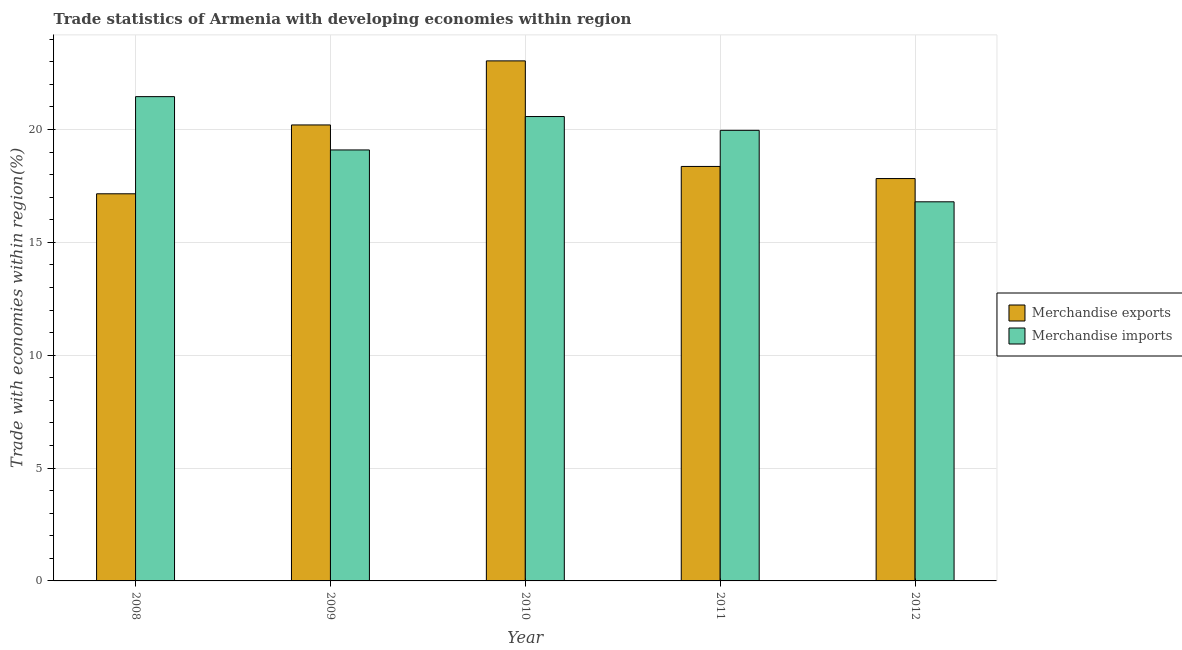How many different coloured bars are there?
Offer a very short reply. 2. Are the number of bars per tick equal to the number of legend labels?
Keep it short and to the point. Yes. Are the number of bars on each tick of the X-axis equal?
Provide a short and direct response. Yes. How many bars are there on the 4th tick from the left?
Your answer should be compact. 2. How many bars are there on the 4th tick from the right?
Provide a succinct answer. 2. What is the label of the 3rd group of bars from the left?
Offer a terse response. 2010. What is the merchandise exports in 2010?
Offer a terse response. 23.04. Across all years, what is the maximum merchandise imports?
Make the answer very short. 21.45. Across all years, what is the minimum merchandise imports?
Make the answer very short. 16.79. What is the total merchandise exports in the graph?
Your answer should be compact. 96.57. What is the difference between the merchandise exports in 2009 and that in 2011?
Offer a terse response. 1.84. What is the difference between the merchandise imports in 2012 and the merchandise exports in 2008?
Give a very brief answer. -4.66. What is the average merchandise exports per year?
Offer a terse response. 19.31. What is the ratio of the merchandise imports in 2010 to that in 2011?
Give a very brief answer. 1.03. Is the difference between the merchandise imports in 2008 and 2010 greater than the difference between the merchandise exports in 2008 and 2010?
Your response must be concise. No. What is the difference between the highest and the second highest merchandise imports?
Offer a terse response. 0.88. What is the difference between the highest and the lowest merchandise imports?
Offer a very short reply. 4.66. In how many years, is the merchandise imports greater than the average merchandise imports taken over all years?
Make the answer very short. 3. Is the sum of the merchandise imports in 2008 and 2010 greater than the maximum merchandise exports across all years?
Ensure brevity in your answer.  Yes. What does the 1st bar from the left in 2008 represents?
Provide a succinct answer. Merchandise exports. How many bars are there?
Offer a very short reply. 10. Does the graph contain any zero values?
Your answer should be compact. No. Does the graph contain grids?
Give a very brief answer. Yes. How are the legend labels stacked?
Provide a short and direct response. Vertical. What is the title of the graph?
Offer a very short reply. Trade statistics of Armenia with developing economies within region. Does "Sanitation services" appear as one of the legend labels in the graph?
Make the answer very short. No. What is the label or title of the X-axis?
Offer a terse response. Year. What is the label or title of the Y-axis?
Ensure brevity in your answer.  Trade with economies within region(%). What is the Trade with economies within region(%) in Merchandise exports in 2008?
Provide a succinct answer. 17.15. What is the Trade with economies within region(%) in Merchandise imports in 2008?
Offer a very short reply. 21.45. What is the Trade with economies within region(%) of Merchandise exports in 2009?
Give a very brief answer. 20.2. What is the Trade with economies within region(%) in Merchandise imports in 2009?
Provide a short and direct response. 19.09. What is the Trade with economies within region(%) in Merchandise exports in 2010?
Keep it short and to the point. 23.04. What is the Trade with economies within region(%) in Merchandise imports in 2010?
Keep it short and to the point. 20.57. What is the Trade with economies within region(%) in Merchandise exports in 2011?
Make the answer very short. 18.36. What is the Trade with economies within region(%) of Merchandise imports in 2011?
Offer a terse response. 19.96. What is the Trade with economies within region(%) of Merchandise exports in 2012?
Make the answer very short. 17.82. What is the Trade with economies within region(%) of Merchandise imports in 2012?
Provide a succinct answer. 16.79. Across all years, what is the maximum Trade with economies within region(%) in Merchandise exports?
Give a very brief answer. 23.04. Across all years, what is the maximum Trade with economies within region(%) in Merchandise imports?
Your response must be concise. 21.45. Across all years, what is the minimum Trade with economies within region(%) in Merchandise exports?
Offer a terse response. 17.15. Across all years, what is the minimum Trade with economies within region(%) in Merchandise imports?
Provide a succinct answer. 16.79. What is the total Trade with economies within region(%) in Merchandise exports in the graph?
Keep it short and to the point. 96.57. What is the total Trade with economies within region(%) in Merchandise imports in the graph?
Offer a very short reply. 97.87. What is the difference between the Trade with economies within region(%) of Merchandise exports in 2008 and that in 2009?
Offer a very short reply. -3.05. What is the difference between the Trade with economies within region(%) of Merchandise imports in 2008 and that in 2009?
Ensure brevity in your answer.  2.36. What is the difference between the Trade with economies within region(%) of Merchandise exports in 2008 and that in 2010?
Offer a terse response. -5.89. What is the difference between the Trade with economies within region(%) of Merchandise imports in 2008 and that in 2010?
Offer a terse response. 0.88. What is the difference between the Trade with economies within region(%) of Merchandise exports in 2008 and that in 2011?
Your response must be concise. -1.21. What is the difference between the Trade with economies within region(%) of Merchandise imports in 2008 and that in 2011?
Ensure brevity in your answer.  1.49. What is the difference between the Trade with economies within region(%) in Merchandise exports in 2008 and that in 2012?
Offer a terse response. -0.67. What is the difference between the Trade with economies within region(%) of Merchandise imports in 2008 and that in 2012?
Offer a terse response. 4.66. What is the difference between the Trade with economies within region(%) in Merchandise exports in 2009 and that in 2010?
Offer a very short reply. -2.84. What is the difference between the Trade with economies within region(%) in Merchandise imports in 2009 and that in 2010?
Offer a terse response. -1.48. What is the difference between the Trade with economies within region(%) of Merchandise exports in 2009 and that in 2011?
Your answer should be very brief. 1.84. What is the difference between the Trade with economies within region(%) in Merchandise imports in 2009 and that in 2011?
Offer a terse response. -0.87. What is the difference between the Trade with economies within region(%) of Merchandise exports in 2009 and that in 2012?
Your answer should be very brief. 2.38. What is the difference between the Trade with economies within region(%) of Merchandise imports in 2009 and that in 2012?
Offer a terse response. 2.3. What is the difference between the Trade with economies within region(%) of Merchandise exports in 2010 and that in 2011?
Your answer should be very brief. 4.68. What is the difference between the Trade with economies within region(%) of Merchandise imports in 2010 and that in 2011?
Give a very brief answer. 0.61. What is the difference between the Trade with economies within region(%) of Merchandise exports in 2010 and that in 2012?
Your answer should be compact. 5.21. What is the difference between the Trade with economies within region(%) of Merchandise imports in 2010 and that in 2012?
Your answer should be compact. 3.78. What is the difference between the Trade with economies within region(%) in Merchandise exports in 2011 and that in 2012?
Your response must be concise. 0.54. What is the difference between the Trade with economies within region(%) of Merchandise imports in 2011 and that in 2012?
Your answer should be very brief. 3.17. What is the difference between the Trade with economies within region(%) of Merchandise exports in 2008 and the Trade with economies within region(%) of Merchandise imports in 2009?
Your answer should be compact. -1.94. What is the difference between the Trade with economies within region(%) in Merchandise exports in 2008 and the Trade with economies within region(%) in Merchandise imports in 2010?
Ensure brevity in your answer.  -3.42. What is the difference between the Trade with economies within region(%) of Merchandise exports in 2008 and the Trade with economies within region(%) of Merchandise imports in 2011?
Your answer should be compact. -2.81. What is the difference between the Trade with economies within region(%) in Merchandise exports in 2008 and the Trade with economies within region(%) in Merchandise imports in 2012?
Your response must be concise. 0.36. What is the difference between the Trade with economies within region(%) of Merchandise exports in 2009 and the Trade with economies within region(%) of Merchandise imports in 2010?
Your response must be concise. -0.37. What is the difference between the Trade with economies within region(%) in Merchandise exports in 2009 and the Trade with economies within region(%) in Merchandise imports in 2011?
Offer a very short reply. 0.24. What is the difference between the Trade with economies within region(%) in Merchandise exports in 2009 and the Trade with economies within region(%) in Merchandise imports in 2012?
Provide a succinct answer. 3.41. What is the difference between the Trade with economies within region(%) of Merchandise exports in 2010 and the Trade with economies within region(%) of Merchandise imports in 2011?
Offer a very short reply. 3.08. What is the difference between the Trade with economies within region(%) of Merchandise exports in 2010 and the Trade with economies within region(%) of Merchandise imports in 2012?
Offer a very short reply. 6.24. What is the difference between the Trade with economies within region(%) in Merchandise exports in 2011 and the Trade with economies within region(%) in Merchandise imports in 2012?
Provide a succinct answer. 1.57. What is the average Trade with economies within region(%) in Merchandise exports per year?
Ensure brevity in your answer.  19.31. What is the average Trade with economies within region(%) in Merchandise imports per year?
Your answer should be very brief. 19.57. In the year 2008, what is the difference between the Trade with economies within region(%) in Merchandise exports and Trade with economies within region(%) in Merchandise imports?
Offer a terse response. -4.3. In the year 2009, what is the difference between the Trade with economies within region(%) of Merchandise exports and Trade with economies within region(%) of Merchandise imports?
Keep it short and to the point. 1.11. In the year 2010, what is the difference between the Trade with economies within region(%) in Merchandise exports and Trade with economies within region(%) in Merchandise imports?
Your answer should be very brief. 2.47. In the year 2011, what is the difference between the Trade with economies within region(%) of Merchandise exports and Trade with economies within region(%) of Merchandise imports?
Offer a terse response. -1.6. In the year 2012, what is the difference between the Trade with economies within region(%) of Merchandise exports and Trade with economies within region(%) of Merchandise imports?
Your answer should be very brief. 1.03. What is the ratio of the Trade with economies within region(%) of Merchandise exports in 2008 to that in 2009?
Give a very brief answer. 0.85. What is the ratio of the Trade with economies within region(%) in Merchandise imports in 2008 to that in 2009?
Your response must be concise. 1.12. What is the ratio of the Trade with economies within region(%) of Merchandise exports in 2008 to that in 2010?
Provide a succinct answer. 0.74. What is the ratio of the Trade with economies within region(%) of Merchandise imports in 2008 to that in 2010?
Give a very brief answer. 1.04. What is the ratio of the Trade with economies within region(%) in Merchandise exports in 2008 to that in 2011?
Your answer should be compact. 0.93. What is the ratio of the Trade with economies within region(%) of Merchandise imports in 2008 to that in 2011?
Offer a terse response. 1.07. What is the ratio of the Trade with economies within region(%) of Merchandise exports in 2008 to that in 2012?
Offer a terse response. 0.96. What is the ratio of the Trade with economies within region(%) of Merchandise imports in 2008 to that in 2012?
Provide a succinct answer. 1.28. What is the ratio of the Trade with economies within region(%) in Merchandise exports in 2009 to that in 2010?
Make the answer very short. 0.88. What is the ratio of the Trade with economies within region(%) in Merchandise imports in 2009 to that in 2010?
Offer a terse response. 0.93. What is the ratio of the Trade with economies within region(%) in Merchandise exports in 2009 to that in 2011?
Make the answer very short. 1.1. What is the ratio of the Trade with economies within region(%) in Merchandise imports in 2009 to that in 2011?
Make the answer very short. 0.96. What is the ratio of the Trade with economies within region(%) of Merchandise exports in 2009 to that in 2012?
Offer a terse response. 1.13. What is the ratio of the Trade with economies within region(%) in Merchandise imports in 2009 to that in 2012?
Your answer should be compact. 1.14. What is the ratio of the Trade with economies within region(%) of Merchandise exports in 2010 to that in 2011?
Ensure brevity in your answer.  1.25. What is the ratio of the Trade with economies within region(%) of Merchandise imports in 2010 to that in 2011?
Offer a very short reply. 1.03. What is the ratio of the Trade with economies within region(%) in Merchandise exports in 2010 to that in 2012?
Offer a very short reply. 1.29. What is the ratio of the Trade with economies within region(%) of Merchandise imports in 2010 to that in 2012?
Provide a short and direct response. 1.22. What is the ratio of the Trade with economies within region(%) in Merchandise exports in 2011 to that in 2012?
Make the answer very short. 1.03. What is the ratio of the Trade with economies within region(%) in Merchandise imports in 2011 to that in 2012?
Keep it short and to the point. 1.19. What is the difference between the highest and the second highest Trade with economies within region(%) of Merchandise exports?
Your answer should be very brief. 2.84. What is the difference between the highest and the second highest Trade with economies within region(%) of Merchandise imports?
Give a very brief answer. 0.88. What is the difference between the highest and the lowest Trade with economies within region(%) in Merchandise exports?
Make the answer very short. 5.89. What is the difference between the highest and the lowest Trade with economies within region(%) in Merchandise imports?
Ensure brevity in your answer.  4.66. 